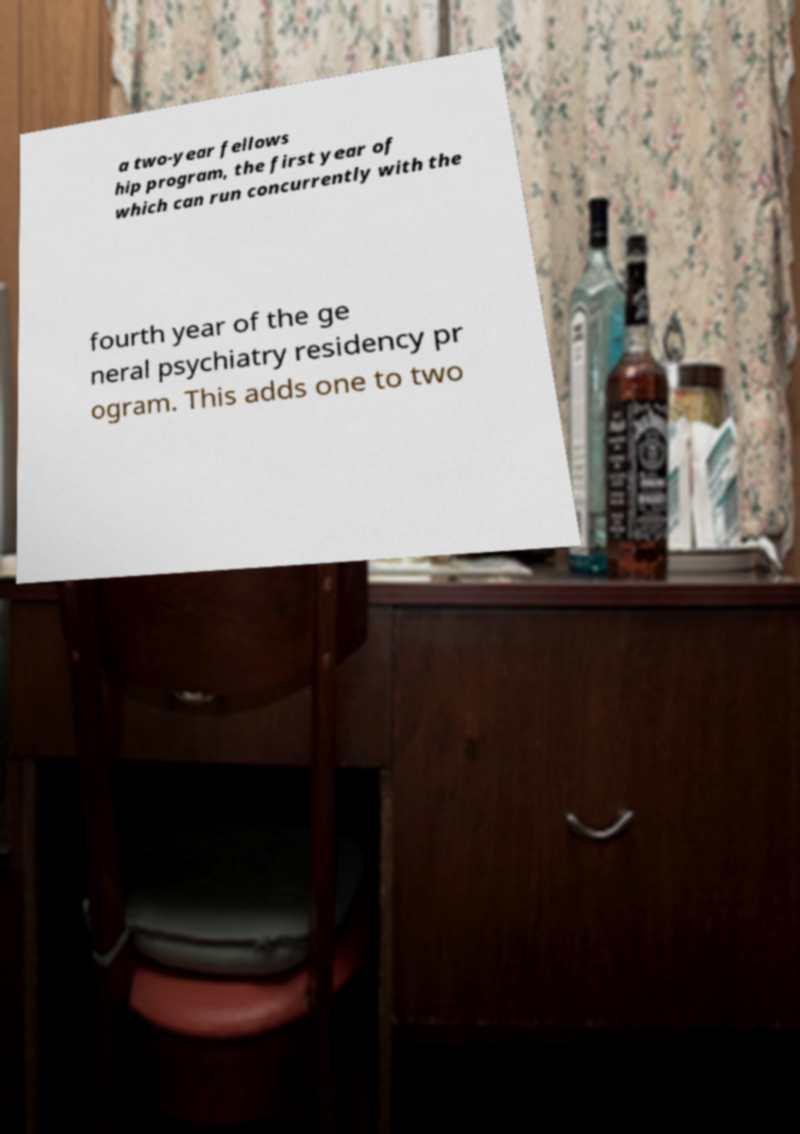Could you assist in decoding the text presented in this image and type it out clearly? a two-year fellows hip program, the first year of which can run concurrently with the fourth year of the ge neral psychiatry residency pr ogram. This adds one to two 